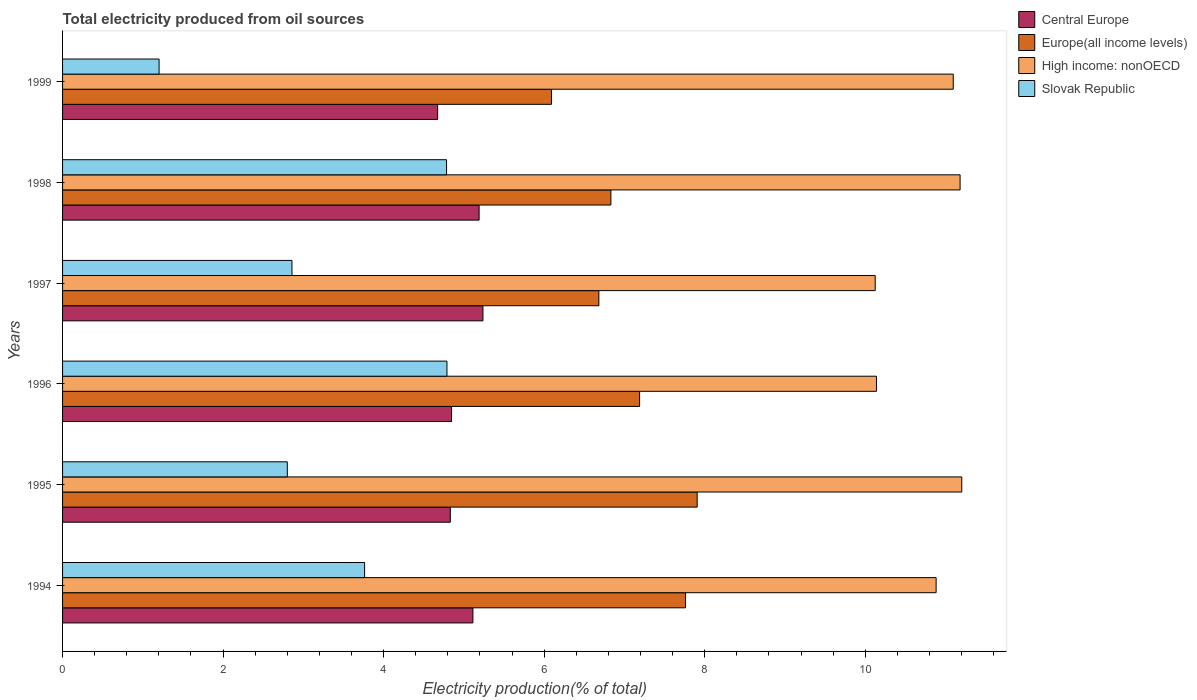How many different coloured bars are there?
Provide a succinct answer. 4. How many groups of bars are there?
Your answer should be compact. 6. Are the number of bars per tick equal to the number of legend labels?
Provide a succinct answer. Yes. Are the number of bars on each tick of the Y-axis equal?
Offer a terse response. Yes. What is the label of the 3rd group of bars from the top?
Offer a very short reply. 1997. What is the total electricity produced in High income: nonOECD in 1998?
Keep it short and to the point. 11.18. Across all years, what is the maximum total electricity produced in High income: nonOECD?
Ensure brevity in your answer.  11.2. Across all years, what is the minimum total electricity produced in Slovak Republic?
Give a very brief answer. 1.2. In which year was the total electricity produced in Europe(all income levels) minimum?
Your answer should be compact. 1999. What is the total total electricity produced in Europe(all income levels) in the graph?
Your answer should be very brief. 42.46. What is the difference between the total electricity produced in Slovak Republic in 1996 and that in 1998?
Your response must be concise. 0.01. What is the difference between the total electricity produced in High income: nonOECD in 1996 and the total electricity produced in Europe(all income levels) in 1999?
Give a very brief answer. 4.05. What is the average total electricity produced in Central Europe per year?
Offer a very short reply. 4.98. In the year 1999, what is the difference between the total electricity produced in Central Europe and total electricity produced in Slovak Republic?
Your answer should be very brief. 3.47. What is the ratio of the total electricity produced in Central Europe in 1994 to that in 1998?
Your response must be concise. 0.99. Is the total electricity produced in High income: nonOECD in 1996 less than that in 1997?
Make the answer very short. No. Is the difference between the total electricity produced in Central Europe in 1998 and 1999 greater than the difference between the total electricity produced in Slovak Republic in 1998 and 1999?
Your response must be concise. No. What is the difference between the highest and the second highest total electricity produced in High income: nonOECD?
Provide a succinct answer. 0.02. What is the difference between the highest and the lowest total electricity produced in High income: nonOECD?
Give a very brief answer. 1.08. In how many years, is the total electricity produced in Europe(all income levels) greater than the average total electricity produced in Europe(all income levels) taken over all years?
Your response must be concise. 3. Is the sum of the total electricity produced in Europe(all income levels) in 1994 and 1999 greater than the maximum total electricity produced in High income: nonOECD across all years?
Ensure brevity in your answer.  Yes. Is it the case that in every year, the sum of the total electricity produced in Europe(all income levels) and total electricity produced in Slovak Republic is greater than the sum of total electricity produced in High income: nonOECD and total electricity produced in Central Europe?
Your answer should be compact. Yes. What does the 2nd bar from the top in 1996 represents?
Give a very brief answer. High income: nonOECD. What does the 4th bar from the bottom in 1995 represents?
Keep it short and to the point. Slovak Republic. Is it the case that in every year, the sum of the total electricity produced in High income: nonOECD and total electricity produced in Europe(all income levels) is greater than the total electricity produced in Slovak Republic?
Your response must be concise. Yes. How many bars are there?
Your response must be concise. 24. How many years are there in the graph?
Provide a short and direct response. 6. Are the values on the major ticks of X-axis written in scientific E-notation?
Offer a very short reply. No. Does the graph contain grids?
Ensure brevity in your answer.  No. Where does the legend appear in the graph?
Provide a short and direct response. Top right. How are the legend labels stacked?
Your response must be concise. Vertical. What is the title of the graph?
Make the answer very short. Total electricity produced from oil sources. Does "Bolivia" appear as one of the legend labels in the graph?
Provide a succinct answer. No. What is the label or title of the X-axis?
Keep it short and to the point. Electricity production(% of total). What is the label or title of the Y-axis?
Your answer should be compact. Years. What is the Electricity production(% of total) of Central Europe in 1994?
Keep it short and to the point. 5.11. What is the Electricity production(% of total) in Europe(all income levels) in 1994?
Give a very brief answer. 7.76. What is the Electricity production(% of total) of High income: nonOECD in 1994?
Ensure brevity in your answer.  10.88. What is the Electricity production(% of total) in Slovak Republic in 1994?
Give a very brief answer. 3.76. What is the Electricity production(% of total) in Central Europe in 1995?
Keep it short and to the point. 4.83. What is the Electricity production(% of total) of Europe(all income levels) in 1995?
Keep it short and to the point. 7.91. What is the Electricity production(% of total) in High income: nonOECD in 1995?
Offer a very short reply. 11.2. What is the Electricity production(% of total) in Slovak Republic in 1995?
Offer a very short reply. 2.8. What is the Electricity production(% of total) of Central Europe in 1996?
Give a very brief answer. 4.85. What is the Electricity production(% of total) in Europe(all income levels) in 1996?
Offer a terse response. 7.19. What is the Electricity production(% of total) in High income: nonOECD in 1996?
Provide a succinct answer. 10.14. What is the Electricity production(% of total) in Slovak Republic in 1996?
Offer a terse response. 4.79. What is the Electricity production(% of total) in Central Europe in 1997?
Your response must be concise. 5.24. What is the Electricity production(% of total) in Europe(all income levels) in 1997?
Make the answer very short. 6.68. What is the Electricity production(% of total) of High income: nonOECD in 1997?
Make the answer very short. 10.12. What is the Electricity production(% of total) of Slovak Republic in 1997?
Offer a terse response. 2.86. What is the Electricity production(% of total) of Central Europe in 1998?
Your answer should be very brief. 5.19. What is the Electricity production(% of total) in Europe(all income levels) in 1998?
Keep it short and to the point. 6.83. What is the Electricity production(% of total) in High income: nonOECD in 1998?
Give a very brief answer. 11.18. What is the Electricity production(% of total) of Slovak Republic in 1998?
Provide a succinct answer. 4.78. What is the Electricity production(% of total) in Central Europe in 1999?
Give a very brief answer. 4.67. What is the Electricity production(% of total) in Europe(all income levels) in 1999?
Make the answer very short. 6.09. What is the Electricity production(% of total) in High income: nonOECD in 1999?
Your answer should be compact. 11.1. What is the Electricity production(% of total) in Slovak Republic in 1999?
Provide a short and direct response. 1.2. Across all years, what is the maximum Electricity production(% of total) of Central Europe?
Your answer should be compact. 5.24. Across all years, what is the maximum Electricity production(% of total) in Europe(all income levels)?
Your answer should be very brief. 7.91. Across all years, what is the maximum Electricity production(% of total) of High income: nonOECD?
Ensure brevity in your answer.  11.2. Across all years, what is the maximum Electricity production(% of total) of Slovak Republic?
Provide a short and direct response. 4.79. Across all years, what is the minimum Electricity production(% of total) in Central Europe?
Give a very brief answer. 4.67. Across all years, what is the minimum Electricity production(% of total) in Europe(all income levels)?
Provide a succinct answer. 6.09. Across all years, what is the minimum Electricity production(% of total) of High income: nonOECD?
Give a very brief answer. 10.12. Across all years, what is the minimum Electricity production(% of total) of Slovak Republic?
Offer a very short reply. 1.2. What is the total Electricity production(% of total) in Central Europe in the graph?
Your response must be concise. 29.89. What is the total Electricity production(% of total) of Europe(all income levels) in the graph?
Your answer should be compact. 42.46. What is the total Electricity production(% of total) in High income: nonOECD in the graph?
Make the answer very short. 64.63. What is the total Electricity production(% of total) in Slovak Republic in the graph?
Offer a terse response. 20.2. What is the difference between the Electricity production(% of total) of Central Europe in 1994 and that in 1995?
Give a very brief answer. 0.28. What is the difference between the Electricity production(% of total) of Europe(all income levels) in 1994 and that in 1995?
Make the answer very short. -0.14. What is the difference between the Electricity production(% of total) of High income: nonOECD in 1994 and that in 1995?
Offer a terse response. -0.32. What is the difference between the Electricity production(% of total) in Slovak Republic in 1994 and that in 1995?
Your answer should be very brief. 0.96. What is the difference between the Electricity production(% of total) of Central Europe in 1994 and that in 1996?
Your response must be concise. 0.27. What is the difference between the Electricity production(% of total) of Europe(all income levels) in 1994 and that in 1996?
Provide a short and direct response. 0.57. What is the difference between the Electricity production(% of total) in High income: nonOECD in 1994 and that in 1996?
Offer a very short reply. 0.74. What is the difference between the Electricity production(% of total) in Slovak Republic in 1994 and that in 1996?
Keep it short and to the point. -1.03. What is the difference between the Electricity production(% of total) in Central Europe in 1994 and that in 1997?
Your response must be concise. -0.12. What is the difference between the Electricity production(% of total) of Europe(all income levels) in 1994 and that in 1997?
Offer a very short reply. 1.08. What is the difference between the Electricity production(% of total) in High income: nonOECD in 1994 and that in 1997?
Your response must be concise. 0.76. What is the difference between the Electricity production(% of total) in Slovak Republic in 1994 and that in 1997?
Keep it short and to the point. 0.91. What is the difference between the Electricity production(% of total) of Central Europe in 1994 and that in 1998?
Provide a short and direct response. -0.08. What is the difference between the Electricity production(% of total) of Europe(all income levels) in 1994 and that in 1998?
Your answer should be compact. 0.93. What is the difference between the Electricity production(% of total) of High income: nonOECD in 1994 and that in 1998?
Make the answer very short. -0.3. What is the difference between the Electricity production(% of total) of Slovak Republic in 1994 and that in 1998?
Provide a succinct answer. -1.02. What is the difference between the Electricity production(% of total) of Central Europe in 1994 and that in 1999?
Keep it short and to the point. 0.44. What is the difference between the Electricity production(% of total) of Europe(all income levels) in 1994 and that in 1999?
Your response must be concise. 1.67. What is the difference between the Electricity production(% of total) in High income: nonOECD in 1994 and that in 1999?
Your answer should be very brief. -0.21. What is the difference between the Electricity production(% of total) of Slovak Republic in 1994 and that in 1999?
Provide a short and direct response. 2.56. What is the difference between the Electricity production(% of total) in Central Europe in 1995 and that in 1996?
Offer a terse response. -0.02. What is the difference between the Electricity production(% of total) in Europe(all income levels) in 1995 and that in 1996?
Offer a terse response. 0.72. What is the difference between the Electricity production(% of total) of High income: nonOECD in 1995 and that in 1996?
Ensure brevity in your answer.  1.06. What is the difference between the Electricity production(% of total) of Slovak Republic in 1995 and that in 1996?
Provide a short and direct response. -1.99. What is the difference between the Electricity production(% of total) of Central Europe in 1995 and that in 1997?
Keep it short and to the point. -0.41. What is the difference between the Electricity production(% of total) in Europe(all income levels) in 1995 and that in 1997?
Make the answer very short. 1.22. What is the difference between the Electricity production(% of total) of High income: nonOECD in 1995 and that in 1997?
Your answer should be very brief. 1.08. What is the difference between the Electricity production(% of total) of Slovak Republic in 1995 and that in 1997?
Make the answer very short. -0.06. What is the difference between the Electricity production(% of total) of Central Europe in 1995 and that in 1998?
Give a very brief answer. -0.36. What is the difference between the Electricity production(% of total) in Europe(all income levels) in 1995 and that in 1998?
Provide a short and direct response. 1.08. What is the difference between the Electricity production(% of total) of High income: nonOECD in 1995 and that in 1998?
Provide a short and direct response. 0.02. What is the difference between the Electricity production(% of total) in Slovak Republic in 1995 and that in 1998?
Keep it short and to the point. -1.98. What is the difference between the Electricity production(% of total) of Central Europe in 1995 and that in 1999?
Provide a succinct answer. 0.16. What is the difference between the Electricity production(% of total) of Europe(all income levels) in 1995 and that in 1999?
Provide a succinct answer. 1.82. What is the difference between the Electricity production(% of total) of High income: nonOECD in 1995 and that in 1999?
Provide a short and direct response. 0.11. What is the difference between the Electricity production(% of total) of Slovak Republic in 1995 and that in 1999?
Offer a very short reply. 1.6. What is the difference between the Electricity production(% of total) of Central Europe in 1996 and that in 1997?
Give a very brief answer. -0.39. What is the difference between the Electricity production(% of total) in Europe(all income levels) in 1996 and that in 1997?
Your answer should be very brief. 0.51. What is the difference between the Electricity production(% of total) of High income: nonOECD in 1996 and that in 1997?
Provide a short and direct response. 0.02. What is the difference between the Electricity production(% of total) of Slovak Republic in 1996 and that in 1997?
Make the answer very short. 1.93. What is the difference between the Electricity production(% of total) of Central Europe in 1996 and that in 1998?
Offer a terse response. -0.34. What is the difference between the Electricity production(% of total) of Europe(all income levels) in 1996 and that in 1998?
Provide a succinct answer. 0.36. What is the difference between the Electricity production(% of total) of High income: nonOECD in 1996 and that in 1998?
Your answer should be compact. -1.04. What is the difference between the Electricity production(% of total) of Slovak Republic in 1996 and that in 1998?
Your answer should be compact. 0.01. What is the difference between the Electricity production(% of total) of Central Europe in 1996 and that in 1999?
Your answer should be compact. 0.17. What is the difference between the Electricity production(% of total) in Europe(all income levels) in 1996 and that in 1999?
Your answer should be very brief. 1.1. What is the difference between the Electricity production(% of total) of High income: nonOECD in 1996 and that in 1999?
Your response must be concise. -0.96. What is the difference between the Electricity production(% of total) of Slovak Republic in 1996 and that in 1999?
Ensure brevity in your answer.  3.59. What is the difference between the Electricity production(% of total) of Central Europe in 1997 and that in 1998?
Your answer should be very brief. 0.05. What is the difference between the Electricity production(% of total) of Europe(all income levels) in 1997 and that in 1998?
Keep it short and to the point. -0.15. What is the difference between the Electricity production(% of total) in High income: nonOECD in 1997 and that in 1998?
Offer a very short reply. -1.06. What is the difference between the Electricity production(% of total) in Slovak Republic in 1997 and that in 1998?
Offer a very short reply. -1.93. What is the difference between the Electricity production(% of total) in Central Europe in 1997 and that in 1999?
Your response must be concise. 0.56. What is the difference between the Electricity production(% of total) in Europe(all income levels) in 1997 and that in 1999?
Keep it short and to the point. 0.59. What is the difference between the Electricity production(% of total) of High income: nonOECD in 1997 and that in 1999?
Offer a terse response. -0.97. What is the difference between the Electricity production(% of total) of Slovak Republic in 1997 and that in 1999?
Offer a very short reply. 1.66. What is the difference between the Electricity production(% of total) of Central Europe in 1998 and that in 1999?
Give a very brief answer. 0.52. What is the difference between the Electricity production(% of total) in Europe(all income levels) in 1998 and that in 1999?
Your answer should be compact. 0.74. What is the difference between the Electricity production(% of total) in High income: nonOECD in 1998 and that in 1999?
Offer a very short reply. 0.09. What is the difference between the Electricity production(% of total) in Slovak Republic in 1998 and that in 1999?
Your answer should be compact. 3.58. What is the difference between the Electricity production(% of total) in Central Europe in 1994 and the Electricity production(% of total) in Europe(all income levels) in 1995?
Your response must be concise. -2.79. What is the difference between the Electricity production(% of total) of Central Europe in 1994 and the Electricity production(% of total) of High income: nonOECD in 1995?
Make the answer very short. -6.09. What is the difference between the Electricity production(% of total) of Central Europe in 1994 and the Electricity production(% of total) of Slovak Republic in 1995?
Give a very brief answer. 2.31. What is the difference between the Electricity production(% of total) of Europe(all income levels) in 1994 and the Electricity production(% of total) of High income: nonOECD in 1995?
Give a very brief answer. -3.44. What is the difference between the Electricity production(% of total) in Europe(all income levels) in 1994 and the Electricity production(% of total) in Slovak Republic in 1995?
Offer a terse response. 4.96. What is the difference between the Electricity production(% of total) in High income: nonOECD in 1994 and the Electricity production(% of total) in Slovak Republic in 1995?
Provide a succinct answer. 8.08. What is the difference between the Electricity production(% of total) of Central Europe in 1994 and the Electricity production(% of total) of Europe(all income levels) in 1996?
Keep it short and to the point. -2.08. What is the difference between the Electricity production(% of total) of Central Europe in 1994 and the Electricity production(% of total) of High income: nonOECD in 1996?
Provide a short and direct response. -5.03. What is the difference between the Electricity production(% of total) of Central Europe in 1994 and the Electricity production(% of total) of Slovak Republic in 1996?
Offer a terse response. 0.32. What is the difference between the Electricity production(% of total) in Europe(all income levels) in 1994 and the Electricity production(% of total) in High income: nonOECD in 1996?
Provide a succinct answer. -2.38. What is the difference between the Electricity production(% of total) in Europe(all income levels) in 1994 and the Electricity production(% of total) in Slovak Republic in 1996?
Provide a short and direct response. 2.97. What is the difference between the Electricity production(% of total) in High income: nonOECD in 1994 and the Electricity production(% of total) in Slovak Republic in 1996?
Your answer should be very brief. 6.09. What is the difference between the Electricity production(% of total) in Central Europe in 1994 and the Electricity production(% of total) in Europe(all income levels) in 1997?
Provide a short and direct response. -1.57. What is the difference between the Electricity production(% of total) in Central Europe in 1994 and the Electricity production(% of total) in High income: nonOECD in 1997?
Keep it short and to the point. -5.01. What is the difference between the Electricity production(% of total) of Central Europe in 1994 and the Electricity production(% of total) of Slovak Republic in 1997?
Offer a terse response. 2.25. What is the difference between the Electricity production(% of total) in Europe(all income levels) in 1994 and the Electricity production(% of total) in High income: nonOECD in 1997?
Your answer should be very brief. -2.36. What is the difference between the Electricity production(% of total) in Europe(all income levels) in 1994 and the Electricity production(% of total) in Slovak Republic in 1997?
Your answer should be compact. 4.9. What is the difference between the Electricity production(% of total) in High income: nonOECD in 1994 and the Electricity production(% of total) in Slovak Republic in 1997?
Give a very brief answer. 8.03. What is the difference between the Electricity production(% of total) in Central Europe in 1994 and the Electricity production(% of total) in Europe(all income levels) in 1998?
Offer a very short reply. -1.72. What is the difference between the Electricity production(% of total) in Central Europe in 1994 and the Electricity production(% of total) in High income: nonOECD in 1998?
Give a very brief answer. -6.07. What is the difference between the Electricity production(% of total) of Central Europe in 1994 and the Electricity production(% of total) of Slovak Republic in 1998?
Give a very brief answer. 0.33. What is the difference between the Electricity production(% of total) in Europe(all income levels) in 1994 and the Electricity production(% of total) in High income: nonOECD in 1998?
Give a very brief answer. -3.42. What is the difference between the Electricity production(% of total) in Europe(all income levels) in 1994 and the Electricity production(% of total) in Slovak Republic in 1998?
Provide a short and direct response. 2.98. What is the difference between the Electricity production(% of total) in High income: nonOECD in 1994 and the Electricity production(% of total) in Slovak Republic in 1998?
Offer a very short reply. 6.1. What is the difference between the Electricity production(% of total) of Central Europe in 1994 and the Electricity production(% of total) of Europe(all income levels) in 1999?
Keep it short and to the point. -0.98. What is the difference between the Electricity production(% of total) in Central Europe in 1994 and the Electricity production(% of total) in High income: nonOECD in 1999?
Your answer should be very brief. -5.98. What is the difference between the Electricity production(% of total) in Central Europe in 1994 and the Electricity production(% of total) in Slovak Republic in 1999?
Provide a short and direct response. 3.91. What is the difference between the Electricity production(% of total) in Europe(all income levels) in 1994 and the Electricity production(% of total) in High income: nonOECD in 1999?
Offer a very short reply. -3.34. What is the difference between the Electricity production(% of total) of Europe(all income levels) in 1994 and the Electricity production(% of total) of Slovak Republic in 1999?
Your response must be concise. 6.56. What is the difference between the Electricity production(% of total) in High income: nonOECD in 1994 and the Electricity production(% of total) in Slovak Republic in 1999?
Offer a very short reply. 9.68. What is the difference between the Electricity production(% of total) of Central Europe in 1995 and the Electricity production(% of total) of Europe(all income levels) in 1996?
Offer a very short reply. -2.36. What is the difference between the Electricity production(% of total) in Central Europe in 1995 and the Electricity production(% of total) in High income: nonOECD in 1996?
Give a very brief answer. -5.31. What is the difference between the Electricity production(% of total) of Central Europe in 1995 and the Electricity production(% of total) of Slovak Republic in 1996?
Offer a very short reply. 0.04. What is the difference between the Electricity production(% of total) of Europe(all income levels) in 1995 and the Electricity production(% of total) of High income: nonOECD in 1996?
Give a very brief answer. -2.23. What is the difference between the Electricity production(% of total) in Europe(all income levels) in 1995 and the Electricity production(% of total) in Slovak Republic in 1996?
Keep it short and to the point. 3.12. What is the difference between the Electricity production(% of total) in High income: nonOECD in 1995 and the Electricity production(% of total) in Slovak Republic in 1996?
Your answer should be very brief. 6.41. What is the difference between the Electricity production(% of total) of Central Europe in 1995 and the Electricity production(% of total) of Europe(all income levels) in 1997?
Give a very brief answer. -1.85. What is the difference between the Electricity production(% of total) of Central Europe in 1995 and the Electricity production(% of total) of High income: nonOECD in 1997?
Offer a terse response. -5.29. What is the difference between the Electricity production(% of total) of Central Europe in 1995 and the Electricity production(% of total) of Slovak Republic in 1997?
Keep it short and to the point. 1.97. What is the difference between the Electricity production(% of total) in Europe(all income levels) in 1995 and the Electricity production(% of total) in High income: nonOECD in 1997?
Make the answer very short. -2.22. What is the difference between the Electricity production(% of total) in Europe(all income levels) in 1995 and the Electricity production(% of total) in Slovak Republic in 1997?
Your response must be concise. 5.05. What is the difference between the Electricity production(% of total) in High income: nonOECD in 1995 and the Electricity production(% of total) in Slovak Republic in 1997?
Your answer should be very brief. 8.34. What is the difference between the Electricity production(% of total) in Central Europe in 1995 and the Electricity production(% of total) in Europe(all income levels) in 1998?
Offer a terse response. -2. What is the difference between the Electricity production(% of total) in Central Europe in 1995 and the Electricity production(% of total) in High income: nonOECD in 1998?
Offer a terse response. -6.35. What is the difference between the Electricity production(% of total) of Central Europe in 1995 and the Electricity production(% of total) of Slovak Republic in 1998?
Ensure brevity in your answer.  0.05. What is the difference between the Electricity production(% of total) in Europe(all income levels) in 1995 and the Electricity production(% of total) in High income: nonOECD in 1998?
Your response must be concise. -3.28. What is the difference between the Electricity production(% of total) in Europe(all income levels) in 1995 and the Electricity production(% of total) in Slovak Republic in 1998?
Your answer should be very brief. 3.12. What is the difference between the Electricity production(% of total) in High income: nonOECD in 1995 and the Electricity production(% of total) in Slovak Republic in 1998?
Provide a short and direct response. 6.42. What is the difference between the Electricity production(% of total) in Central Europe in 1995 and the Electricity production(% of total) in Europe(all income levels) in 1999?
Your response must be concise. -1.26. What is the difference between the Electricity production(% of total) of Central Europe in 1995 and the Electricity production(% of total) of High income: nonOECD in 1999?
Make the answer very short. -6.27. What is the difference between the Electricity production(% of total) of Central Europe in 1995 and the Electricity production(% of total) of Slovak Republic in 1999?
Provide a succinct answer. 3.63. What is the difference between the Electricity production(% of total) of Europe(all income levels) in 1995 and the Electricity production(% of total) of High income: nonOECD in 1999?
Your answer should be compact. -3.19. What is the difference between the Electricity production(% of total) in Europe(all income levels) in 1995 and the Electricity production(% of total) in Slovak Republic in 1999?
Make the answer very short. 6.7. What is the difference between the Electricity production(% of total) of High income: nonOECD in 1995 and the Electricity production(% of total) of Slovak Republic in 1999?
Provide a succinct answer. 10. What is the difference between the Electricity production(% of total) of Central Europe in 1996 and the Electricity production(% of total) of Europe(all income levels) in 1997?
Provide a succinct answer. -1.84. What is the difference between the Electricity production(% of total) of Central Europe in 1996 and the Electricity production(% of total) of High income: nonOECD in 1997?
Ensure brevity in your answer.  -5.28. What is the difference between the Electricity production(% of total) of Central Europe in 1996 and the Electricity production(% of total) of Slovak Republic in 1997?
Your answer should be very brief. 1.99. What is the difference between the Electricity production(% of total) of Europe(all income levels) in 1996 and the Electricity production(% of total) of High income: nonOECD in 1997?
Give a very brief answer. -2.94. What is the difference between the Electricity production(% of total) in Europe(all income levels) in 1996 and the Electricity production(% of total) in Slovak Republic in 1997?
Your answer should be very brief. 4.33. What is the difference between the Electricity production(% of total) in High income: nonOECD in 1996 and the Electricity production(% of total) in Slovak Republic in 1997?
Make the answer very short. 7.28. What is the difference between the Electricity production(% of total) of Central Europe in 1996 and the Electricity production(% of total) of Europe(all income levels) in 1998?
Make the answer very short. -1.98. What is the difference between the Electricity production(% of total) in Central Europe in 1996 and the Electricity production(% of total) in High income: nonOECD in 1998?
Provide a short and direct response. -6.34. What is the difference between the Electricity production(% of total) of Central Europe in 1996 and the Electricity production(% of total) of Slovak Republic in 1998?
Your answer should be compact. 0.06. What is the difference between the Electricity production(% of total) in Europe(all income levels) in 1996 and the Electricity production(% of total) in High income: nonOECD in 1998?
Provide a short and direct response. -3.99. What is the difference between the Electricity production(% of total) of Europe(all income levels) in 1996 and the Electricity production(% of total) of Slovak Republic in 1998?
Your answer should be compact. 2.41. What is the difference between the Electricity production(% of total) in High income: nonOECD in 1996 and the Electricity production(% of total) in Slovak Republic in 1998?
Ensure brevity in your answer.  5.36. What is the difference between the Electricity production(% of total) of Central Europe in 1996 and the Electricity production(% of total) of Europe(all income levels) in 1999?
Provide a succinct answer. -1.24. What is the difference between the Electricity production(% of total) of Central Europe in 1996 and the Electricity production(% of total) of High income: nonOECD in 1999?
Give a very brief answer. -6.25. What is the difference between the Electricity production(% of total) of Central Europe in 1996 and the Electricity production(% of total) of Slovak Republic in 1999?
Your response must be concise. 3.64. What is the difference between the Electricity production(% of total) of Europe(all income levels) in 1996 and the Electricity production(% of total) of High income: nonOECD in 1999?
Offer a very short reply. -3.91. What is the difference between the Electricity production(% of total) of Europe(all income levels) in 1996 and the Electricity production(% of total) of Slovak Republic in 1999?
Make the answer very short. 5.99. What is the difference between the Electricity production(% of total) in High income: nonOECD in 1996 and the Electricity production(% of total) in Slovak Republic in 1999?
Your answer should be very brief. 8.94. What is the difference between the Electricity production(% of total) in Central Europe in 1997 and the Electricity production(% of total) in Europe(all income levels) in 1998?
Provide a short and direct response. -1.59. What is the difference between the Electricity production(% of total) in Central Europe in 1997 and the Electricity production(% of total) in High income: nonOECD in 1998?
Give a very brief answer. -5.94. What is the difference between the Electricity production(% of total) of Central Europe in 1997 and the Electricity production(% of total) of Slovak Republic in 1998?
Your response must be concise. 0.45. What is the difference between the Electricity production(% of total) of Europe(all income levels) in 1997 and the Electricity production(% of total) of High income: nonOECD in 1998?
Your answer should be very brief. -4.5. What is the difference between the Electricity production(% of total) in Europe(all income levels) in 1997 and the Electricity production(% of total) in Slovak Republic in 1998?
Provide a short and direct response. 1.9. What is the difference between the Electricity production(% of total) of High income: nonOECD in 1997 and the Electricity production(% of total) of Slovak Republic in 1998?
Offer a terse response. 5.34. What is the difference between the Electricity production(% of total) in Central Europe in 1997 and the Electricity production(% of total) in Europe(all income levels) in 1999?
Offer a very short reply. -0.85. What is the difference between the Electricity production(% of total) in Central Europe in 1997 and the Electricity production(% of total) in High income: nonOECD in 1999?
Provide a short and direct response. -5.86. What is the difference between the Electricity production(% of total) in Central Europe in 1997 and the Electricity production(% of total) in Slovak Republic in 1999?
Offer a very short reply. 4.03. What is the difference between the Electricity production(% of total) of Europe(all income levels) in 1997 and the Electricity production(% of total) of High income: nonOECD in 1999?
Ensure brevity in your answer.  -4.42. What is the difference between the Electricity production(% of total) of Europe(all income levels) in 1997 and the Electricity production(% of total) of Slovak Republic in 1999?
Offer a very short reply. 5.48. What is the difference between the Electricity production(% of total) in High income: nonOECD in 1997 and the Electricity production(% of total) in Slovak Republic in 1999?
Your answer should be very brief. 8.92. What is the difference between the Electricity production(% of total) in Central Europe in 1998 and the Electricity production(% of total) in Europe(all income levels) in 1999?
Ensure brevity in your answer.  -0.9. What is the difference between the Electricity production(% of total) in Central Europe in 1998 and the Electricity production(% of total) in High income: nonOECD in 1999?
Make the answer very short. -5.91. What is the difference between the Electricity production(% of total) of Central Europe in 1998 and the Electricity production(% of total) of Slovak Republic in 1999?
Your answer should be compact. 3.99. What is the difference between the Electricity production(% of total) of Europe(all income levels) in 1998 and the Electricity production(% of total) of High income: nonOECD in 1999?
Ensure brevity in your answer.  -4.27. What is the difference between the Electricity production(% of total) in Europe(all income levels) in 1998 and the Electricity production(% of total) in Slovak Republic in 1999?
Keep it short and to the point. 5.63. What is the difference between the Electricity production(% of total) in High income: nonOECD in 1998 and the Electricity production(% of total) in Slovak Republic in 1999?
Offer a very short reply. 9.98. What is the average Electricity production(% of total) of Central Europe per year?
Offer a terse response. 4.98. What is the average Electricity production(% of total) in Europe(all income levels) per year?
Make the answer very short. 7.08. What is the average Electricity production(% of total) in High income: nonOECD per year?
Your response must be concise. 10.77. What is the average Electricity production(% of total) of Slovak Republic per year?
Your response must be concise. 3.37. In the year 1994, what is the difference between the Electricity production(% of total) of Central Europe and Electricity production(% of total) of Europe(all income levels)?
Provide a short and direct response. -2.65. In the year 1994, what is the difference between the Electricity production(% of total) in Central Europe and Electricity production(% of total) in High income: nonOECD?
Provide a short and direct response. -5.77. In the year 1994, what is the difference between the Electricity production(% of total) in Central Europe and Electricity production(% of total) in Slovak Republic?
Your answer should be compact. 1.35. In the year 1994, what is the difference between the Electricity production(% of total) in Europe(all income levels) and Electricity production(% of total) in High income: nonOECD?
Keep it short and to the point. -3.12. In the year 1994, what is the difference between the Electricity production(% of total) in Europe(all income levels) and Electricity production(% of total) in Slovak Republic?
Offer a very short reply. 4. In the year 1994, what is the difference between the Electricity production(% of total) of High income: nonOECD and Electricity production(% of total) of Slovak Republic?
Your answer should be compact. 7.12. In the year 1995, what is the difference between the Electricity production(% of total) in Central Europe and Electricity production(% of total) in Europe(all income levels)?
Your response must be concise. -3.08. In the year 1995, what is the difference between the Electricity production(% of total) in Central Europe and Electricity production(% of total) in High income: nonOECD?
Offer a very short reply. -6.37. In the year 1995, what is the difference between the Electricity production(% of total) in Central Europe and Electricity production(% of total) in Slovak Republic?
Ensure brevity in your answer.  2.03. In the year 1995, what is the difference between the Electricity production(% of total) of Europe(all income levels) and Electricity production(% of total) of High income: nonOECD?
Your response must be concise. -3.3. In the year 1995, what is the difference between the Electricity production(% of total) in Europe(all income levels) and Electricity production(% of total) in Slovak Republic?
Your answer should be compact. 5.11. In the year 1995, what is the difference between the Electricity production(% of total) of High income: nonOECD and Electricity production(% of total) of Slovak Republic?
Offer a very short reply. 8.4. In the year 1996, what is the difference between the Electricity production(% of total) of Central Europe and Electricity production(% of total) of Europe(all income levels)?
Your answer should be compact. -2.34. In the year 1996, what is the difference between the Electricity production(% of total) in Central Europe and Electricity production(% of total) in High income: nonOECD?
Make the answer very short. -5.29. In the year 1996, what is the difference between the Electricity production(% of total) in Central Europe and Electricity production(% of total) in Slovak Republic?
Ensure brevity in your answer.  0.06. In the year 1996, what is the difference between the Electricity production(% of total) in Europe(all income levels) and Electricity production(% of total) in High income: nonOECD?
Make the answer very short. -2.95. In the year 1996, what is the difference between the Electricity production(% of total) in High income: nonOECD and Electricity production(% of total) in Slovak Republic?
Keep it short and to the point. 5.35. In the year 1997, what is the difference between the Electricity production(% of total) in Central Europe and Electricity production(% of total) in Europe(all income levels)?
Provide a succinct answer. -1.44. In the year 1997, what is the difference between the Electricity production(% of total) of Central Europe and Electricity production(% of total) of High income: nonOECD?
Your response must be concise. -4.89. In the year 1997, what is the difference between the Electricity production(% of total) of Central Europe and Electricity production(% of total) of Slovak Republic?
Offer a terse response. 2.38. In the year 1997, what is the difference between the Electricity production(% of total) in Europe(all income levels) and Electricity production(% of total) in High income: nonOECD?
Your answer should be very brief. -3.44. In the year 1997, what is the difference between the Electricity production(% of total) of Europe(all income levels) and Electricity production(% of total) of Slovak Republic?
Your answer should be very brief. 3.82. In the year 1997, what is the difference between the Electricity production(% of total) in High income: nonOECD and Electricity production(% of total) in Slovak Republic?
Offer a very short reply. 7.27. In the year 1998, what is the difference between the Electricity production(% of total) in Central Europe and Electricity production(% of total) in Europe(all income levels)?
Offer a terse response. -1.64. In the year 1998, what is the difference between the Electricity production(% of total) in Central Europe and Electricity production(% of total) in High income: nonOECD?
Provide a succinct answer. -5.99. In the year 1998, what is the difference between the Electricity production(% of total) of Central Europe and Electricity production(% of total) of Slovak Republic?
Offer a terse response. 0.41. In the year 1998, what is the difference between the Electricity production(% of total) in Europe(all income levels) and Electricity production(% of total) in High income: nonOECD?
Ensure brevity in your answer.  -4.35. In the year 1998, what is the difference between the Electricity production(% of total) of Europe(all income levels) and Electricity production(% of total) of Slovak Republic?
Offer a very short reply. 2.05. In the year 1998, what is the difference between the Electricity production(% of total) of High income: nonOECD and Electricity production(% of total) of Slovak Republic?
Provide a short and direct response. 6.4. In the year 1999, what is the difference between the Electricity production(% of total) in Central Europe and Electricity production(% of total) in Europe(all income levels)?
Your answer should be very brief. -1.42. In the year 1999, what is the difference between the Electricity production(% of total) of Central Europe and Electricity production(% of total) of High income: nonOECD?
Offer a terse response. -6.42. In the year 1999, what is the difference between the Electricity production(% of total) of Central Europe and Electricity production(% of total) of Slovak Republic?
Offer a terse response. 3.47. In the year 1999, what is the difference between the Electricity production(% of total) in Europe(all income levels) and Electricity production(% of total) in High income: nonOECD?
Offer a very short reply. -5.01. In the year 1999, what is the difference between the Electricity production(% of total) in Europe(all income levels) and Electricity production(% of total) in Slovak Republic?
Give a very brief answer. 4.89. In the year 1999, what is the difference between the Electricity production(% of total) in High income: nonOECD and Electricity production(% of total) in Slovak Republic?
Offer a terse response. 9.89. What is the ratio of the Electricity production(% of total) in Central Europe in 1994 to that in 1995?
Your answer should be compact. 1.06. What is the ratio of the Electricity production(% of total) in Europe(all income levels) in 1994 to that in 1995?
Give a very brief answer. 0.98. What is the ratio of the Electricity production(% of total) of High income: nonOECD in 1994 to that in 1995?
Make the answer very short. 0.97. What is the ratio of the Electricity production(% of total) of Slovak Republic in 1994 to that in 1995?
Provide a short and direct response. 1.34. What is the ratio of the Electricity production(% of total) of Central Europe in 1994 to that in 1996?
Keep it short and to the point. 1.05. What is the ratio of the Electricity production(% of total) in Europe(all income levels) in 1994 to that in 1996?
Offer a very short reply. 1.08. What is the ratio of the Electricity production(% of total) of High income: nonOECD in 1994 to that in 1996?
Make the answer very short. 1.07. What is the ratio of the Electricity production(% of total) in Slovak Republic in 1994 to that in 1996?
Provide a short and direct response. 0.79. What is the ratio of the Electricity production(% of total) in Central Europe in 1994 to that in 1997?
Make the answer very short. 0.98. What is the ratio of the Electricity production(% of total) of Europe(all income levels) in 1994 to that in 1997?
Provide a short and direct response. 1.16. What is the ratio of the Electricity production(% of total) of High income: nonOECD in 1994 to that in 1997?
Provide a short and direct response. 1.07. What is the ratio of the Electricity production(% of total) in Slovak Republic in 1994 to that in 1997?
Offer a very short reply. 1.32. What is the ratio of the Electricity production(% of total) in Central Europe in 1994 to that in 1998?
Provide a succinct answer. 0.99. What is the ratio of the Electricity production(% of total) of Europe(all income levels) in 1994 to that in 1998?
Give a very brief answer. 1.14. What is the ratio of the Electricity production(% of total) of High income: nonOECD in 1994 to that in 1998?
Provide a succinct answer. 0.97. What is the ratio of the Electricity production(% of total) in Slovak Republic in 1994 to that in 1998?
Keep it short and to the point. 0.79. What is the ratio of the Electricity production(% of total) in Central Europe in 1994 to that in 1999?
Your answer should be compact. 1.09. What is the ratio of the Electricity production(% of total) of Europe(all income levels) in 1994 to that in 1999?
Give a very brief answer. 1.27. What is the ratio of the Electricity production(% of total) in High income: nonOECD in 1994 to that in 1999?
Offer a terse response. 0.98. What is the ratio of the Electricity production(% of total) of Slovak Republic in 1994 to that in 1999?
Offer a very short reply. 3.13. What is the ratio of the Electricity production(% of total) of Central Europe in 1995 to that in 1996?
Make the answer very short. 1. What is the ratio of the Electricity production(% of total) of Europe(all income levels) in 1995 to that in 1996?
Provide a succinct answer. 1.1. What is the ratio of the Electricity production(% of total) in High income: nonOECD in 1995 to that in 1996?
Offer a very short reply. 1.1. What is the ratio of the Electricity production(% of total) in Slovak Republic in 1995 to that in 1996?
Your response must be concise. 0.58. What is the ratio of the Electricity production(% of total) in Central Europe in 1995 to that in 1997?
Offer a terse response. 0.92. What is the ratio of the Electricity production(% of total) in Europe(all income levels) in 1995 to that in 1997?
Make the answer very short. 1.18. What is the ratio of the Electricity production(% of total) in High income: nonOECD in 1995 to that in 1997?
Make the answer very short. 1.11. What is the ratio of the Electricity production(% of total) in Slovak Republic in 1995 to that in 1997?
Give a very brief answer. 0.98. What is the ratio of the Electricity production(% of total) in Central Europe in 1995 to that in 1998?
Offer a terse response. 0.93. What is the ratio of the Electricity production(% of total) of Europe(all income levels) in 1995 to that in 1998?
Make the answer very short. 1.16. What is the ratio of the Electricity production(% of total) of High income: nonOECD in 1995 to that in 1998?
Offer a terse response. 1. What is the ratio of the Electricity production(% of total) in Slovak Republic in 1995 to that in 1998?
Make the answer very short. 0.59. What is the ratio of the Electricity production(% of total) in Central Europe in 1995 to that in 1999?
Make the answer very short. 1.03. What is the ratio of the Electricity production(% of total) in Europe(all income levels) in 1995 to that in 1999?
Provide a succinct answer. 1.3. What is the ratio of the Electricity production(% of total) of High income: nonOECD in 1995 to that in 1999?
Keep it short and to the point. 1.01. What is the ratio of the Electricity production(% of total) in Slovak Republic in 1995 to that in 1999?
Your response must be concise. 2.33. What is the ratio of the Electricity production(% of total) in Central Europe in 1996 to that in 1997?
Your response must be concise. 0.93. What is the ratio of the Electricity production(% of total) in Europe(all income levels) in 1996 to that in 1997?
Your answer should be compact. 1.08. What is the ratio of the Electricity production(% of total) of Slovak Republic in 1996 to that in 1997?
Offer a very short reply. 1.68. What is the ratio of the Electricity production(% of total) of Central Europe in 1996 to that in 1998?
Your response must be concise. 0.93. What is the ratio of the Electricity production(% of total) in Europe(all income levels) in 1996 to that in 1998?
Ensure brevity in your answer.  1.05. What is the ratio of the Electricity production(% of total) of High income: nonOECD in 1996 to that in 1998?
Your answer should be very brief. 0.91. What is the ratio of the Electricity production(% of total) of Central Europe in 1996 to that in 1999?
Keep it short and to the point. 1.04. What is the ratio of the Electricity production(% of total) in Europe(all income levels) in 1996 to that in 1999?
Give a very brief answer. 1.18. What is the ratio of the Electricity production(% of total) of High income: nonOECD in 1996 to that in 1999?
Your answer should be very brief. 0.91. What is the ratio of the Electricity production(% of total) in Slovak Republic in 1996 to that in 1999?
Keep it short and to the point. 3.98. What is the ratio of the Electricity production(% of total) in Central Europe in 1997 to that in 1998?
Offer a very short reply. 1.01. What is the ratio of the Electricity production(% of total) of Europe(all income levels) in 1997 to that in 1998?
Offer a very short reply. 0.98. What is the ratio of the Electricity production(% of total) in High income: nonOECD in 1997 to that in 1998?
Your answer should be very brief. 0.91. What is the ratio of the Electricity production(% of total) of Slovak Republic in 1997 to that in 1998?
Keep it short and to the point. 0.6. What is the ratio of the Electricity production(% of total) in Central Europe in 1997 to that in 1999?
Your answer should be very brief. 1.12. What is the ratio of the Electricity production(% of total) in Europe(all income levels) in 1997 to that in 1999?
Your answer should be very brief. 1.1. What is the ratio of the Electricity production(% of total) in High income: nonOECD in 1997 to that in 1999?
Your response must be concise. 0.91. What is the ratio of the Electricity production(% of total) in Slovak Republic in 1997 to that in 1999?
Your answer should be very brief. 2.38. What is the ratio of the Electricity production(% of total) of Central Europe in 1998 to that in 1999?
Your answer should be very brief. 1.11. What is the ratio of the Electricity production(% of total) in Europe(all income levels) in 1998 to that in 1999?
Offer a terse response. 1.12. What is the ratio of the Electricity production(% of total) in High income: nonOECD in 1998 to that in 1999?
Ensure brevity in your answer.  1.01. What is the ratio of the Electricity production(% of total) in Slovak Republic in 1998 to that in 1999?
Provide a short and direct response. 3.98. What is the difference between the highest and the second highest Electricity production(% of total) of Central Europe?
Provide a short and direct response. 0.05. What is the difference between the highest and the second highest Electricity production(% of total) in Europe(all income levels)?
Give a very brief answer. 0.14. What is the difference between the highest and the second highest Electricity production(% of total) of High income: nonOECD?
Keep it short and to the point. 0.02. What is the difference between the highest and the second highest Electricity production(% of total) of Slovak Republic?
Provide a short and direct response. 0.01. What is the difference between the highest and the lowest Electricity production(% of total) in Central Europe?
Offer a terse response. 0.56. What is the difference between the highest and the lowest Electricity production(% of total) in Europe(all income levels)?
Your answer should be compact. 1.82. What is the difference between the highest and the lowest Electricity production(% of total) in High income: nonOECD?
Ensure brevity in your answer.  1.08. What is the difference between the highest and the lowest Electricity production(% of total) in Slovak Republic?
Your answer should be compact. 3.59. 